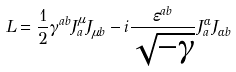<formula> <loc_0><loc_0><loc_500><loc_500>L = \frac { 1 } { 2 } \gamma ^ { a b } J _ { a } ^ { \mu } J _ { \mu b } - i \frac { \varepsilon ^ { a b } } { \sqrt { - \gamma } } J _ { a } ^ { \alpha } J _ { \alpha b }</formula> 